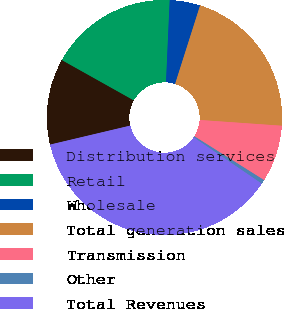<chart> <loc_0><loc_0><loc_500><loc_500><pie_chart><fcel>Distribution services<fcel>Retail<fcel>Wholesale<fcel>Total generation sales<fcel>Transmission<fcel>Other<fcel>Total Revenues<nl><fcel>11.83%<fcel>17.58%<fcel>4.19%<fcel>21.21%<fcel>7.82%<fcel>0.57%<fcel>36.79%<nl></chart> 